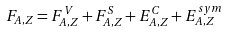<formula> <loc_0><loc_0><loc_500><loc_500>F _ { A , Z } = F ^ { V } _ { A , Z } + F ^ { S } _ { A , Z } + E ^ { C } _ { A , Z } + E ^ { s y m } _ { A , Z }</formula> 